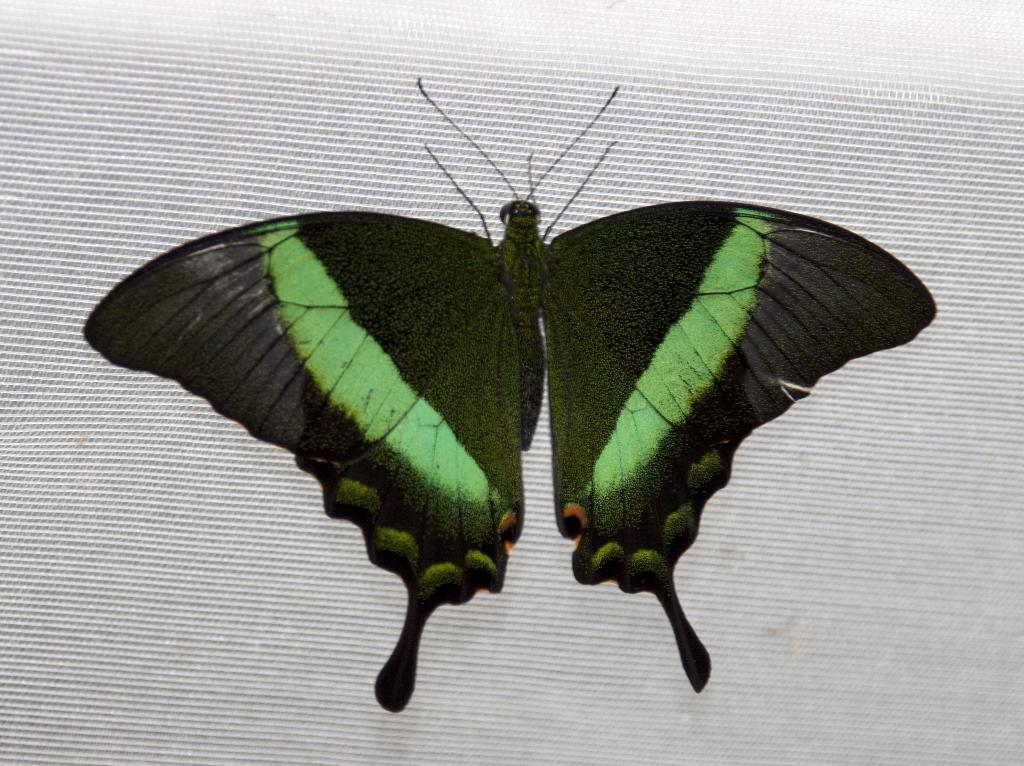What type of insect is present in the image? There is a black color butterfly in the image. What is the butterfly resting on in the image? The butterfly is on a white color object. Can you describe the white color object in the image? The white color object appears to be a window blind. How many mittens are visible in the image? There are no mittens present in the image. What type of cushion is supporting the butterfly in the image? There is no cushion present in the image, and the butterfly is resting on a window blind. 